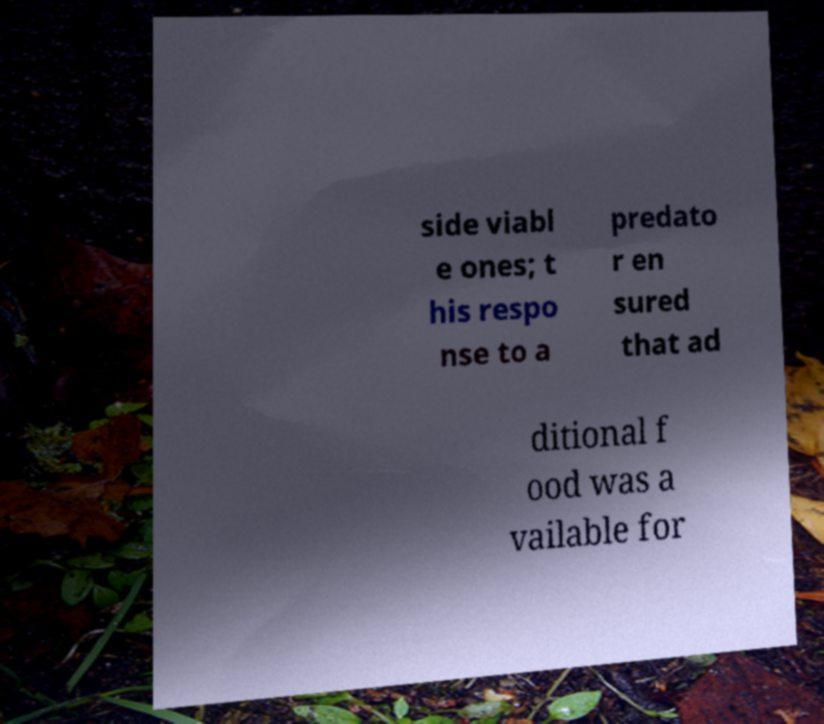I need the written content from this picture converted into text. Can you do that? side viabl e ones; t his respo nse to a predato r en sured that ad ditional f ood was a vailable for 